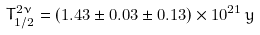<formula> <loc_0><loc_0><loc_500><loc_500>T ^ { 2 \nu } _ { 1 / 2 } = ( 1 . 4 3 \pm 0 . 0 3 \pm 0 . 1 3 ) \times { 1 0 ^ { 2 1 } } \, y</formula> 